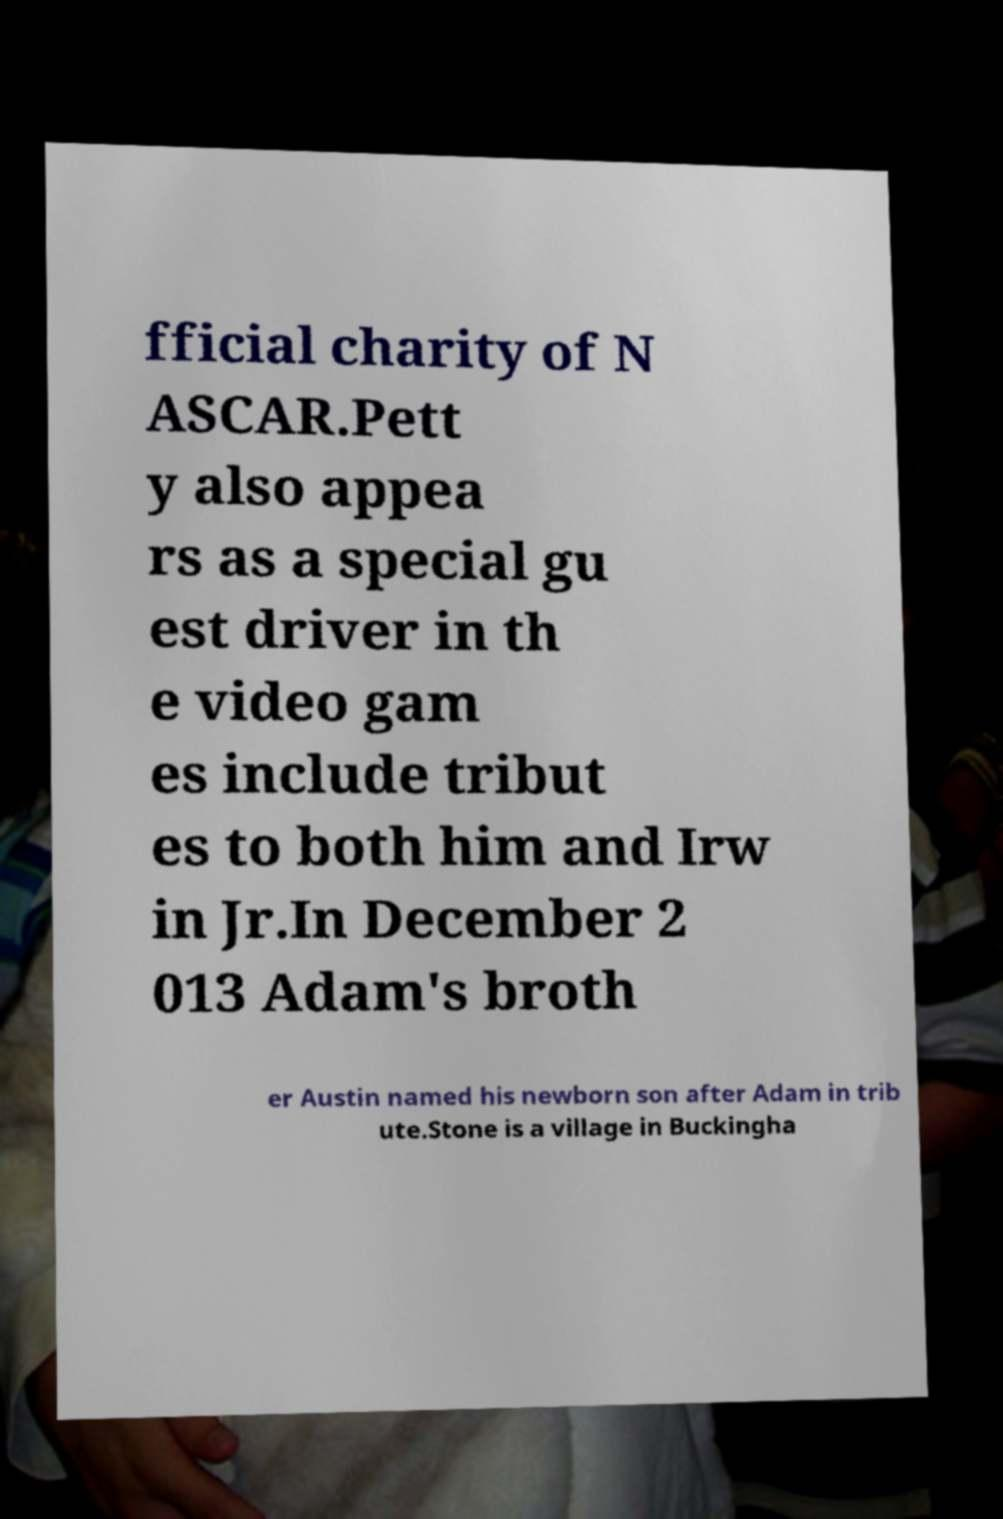Can you read and provide the text displayed in the image?This photo seems to have some interesting text. Can you extract and type it out for me? fficial charity of N ASCAR.Pett y also appea rs as a special gu est driver in th e video gam es include tribut es to both him and Irw in Jr.In December 2 013 Adam's broth er Austin named his newborn son after Adam in trib ute.Stone is a village in Buckingha 